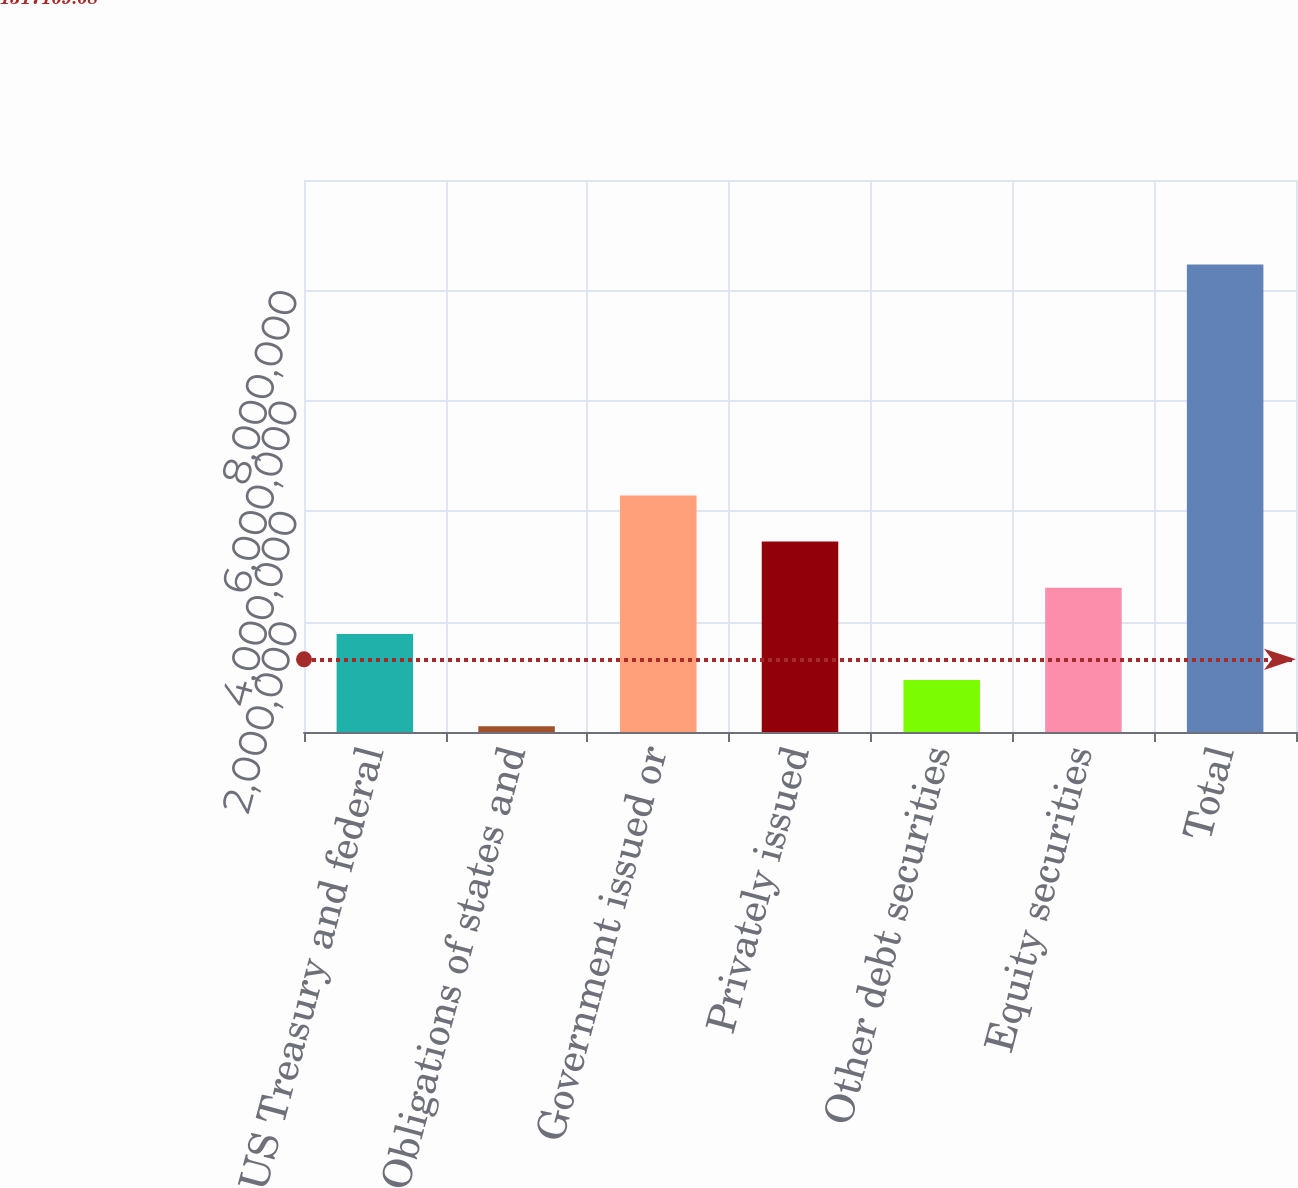Convert chart to OTSL. <chart><loc_0><loc_0><loc_500><loc_500><bar_chart><fcel>US Treasury and federal<fcel>Obligations of states and<fcel>Government issued or<fcel>Privately issued<fcel>Other debt securities<fcel>Equity securities<fcel>Total<nl><fcel>1.77625e+06<fcel>103415<fcel>4.2855e+06<fcel>3.44908e+06<fcel>939832<fcel>2.61267e+06<fcel>8.46758e+06<nl></chart> 